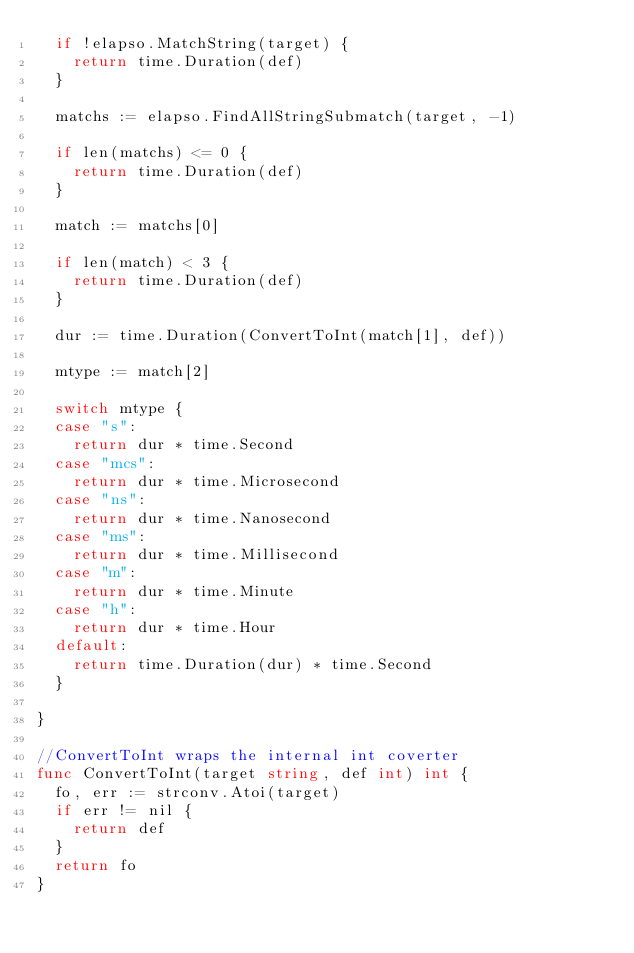Convert code to text. <code><loc_0><loc_0><loc_500><loc_500><_Go_>	if !elapso.MatchString(target) {
		return time.Duration(def)
	}

	matchs := elapso.FindAllStringSubmatch(target, -1)

	if len(matchs) <= 0 {
		return time.Duration(def)
	}

	match := matchs[0]

	if len(match) < 3 {
		return time.Duration(def)
	}

	dur := time.Duration(ConvertToInt(match[1], def))

	mtype := match[2]

	switch mtype {
	case "s":
		return dur * time.Second
	case "mcs":
		return dur * time.Microsecond
	case "ns":
		return dur * time.Nanosecond
	case "ms":
		return dur * time.Millisecond
	case "m":
		return dur * time.Minute
	case "h":
		return dur * time.Hour
	default:
		return time.Duration(dur) * time.Second
	}

}

//ConvertToInt wraps the internal int coverter
func ConvertToInt(target string, def int) int {
	fo, err := strconv.Atoi(target)
	if err != nil {
		return def
	}
	return fo
}
</code> 